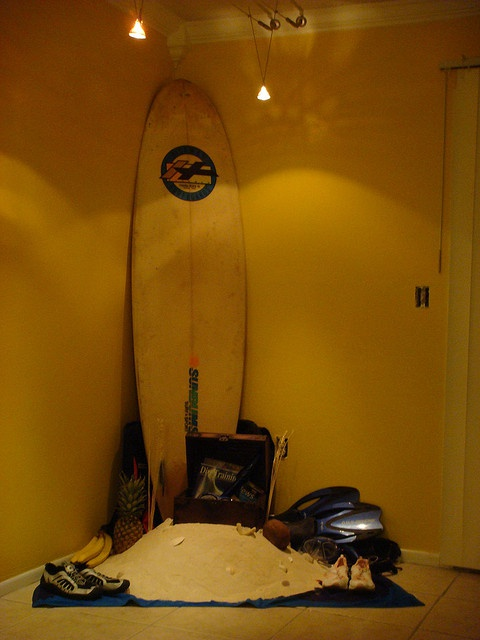Describe the objects in this image and their specific colors. I can see surfboard in maroon, olive, and black tones and banana in maroon, olive, and black tones in this image. 